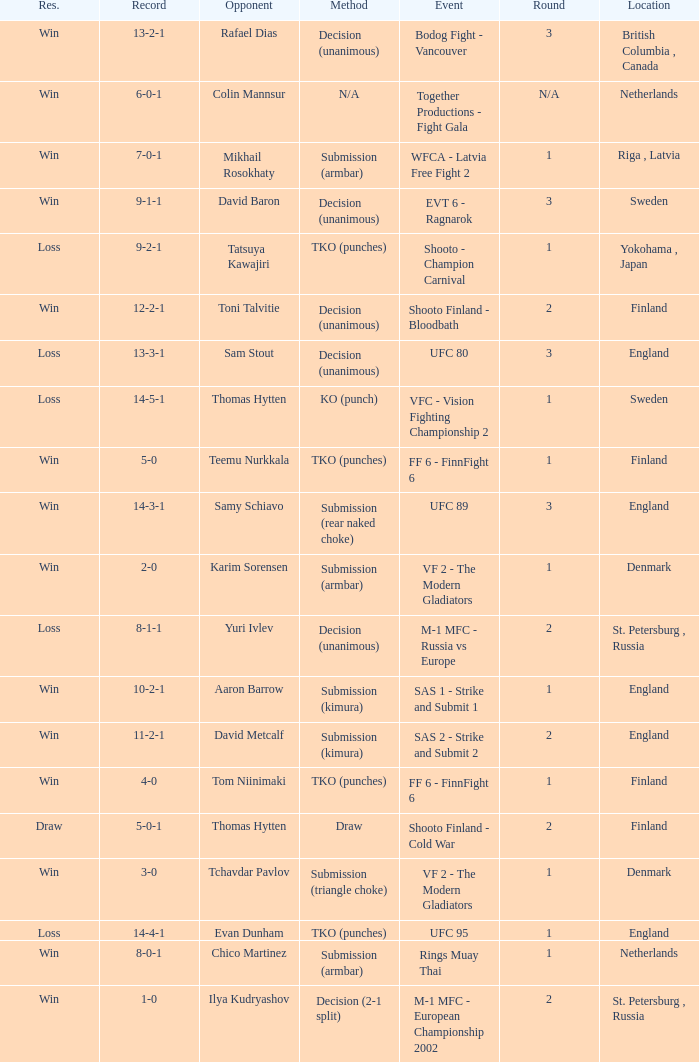What's the location when the record was 6-0-1? Netherlands. 